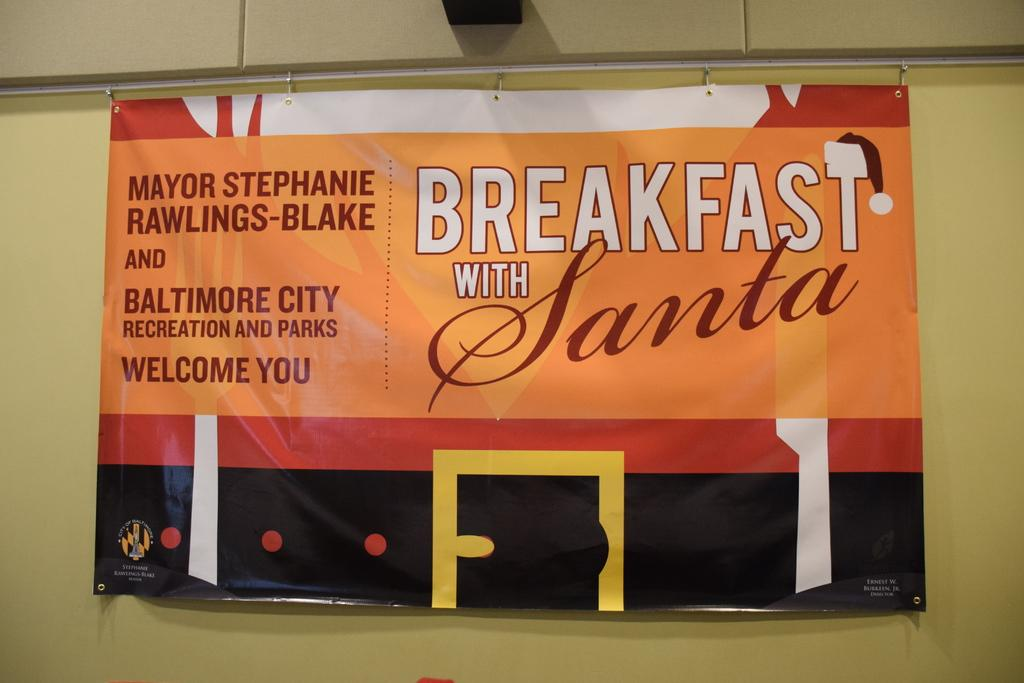<image>
Give a short and clear explanation of the subsequent image. the word breakfast that is on a sign 